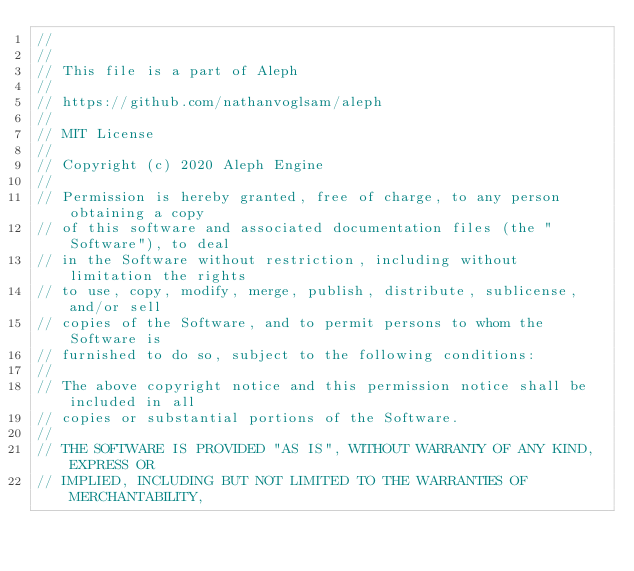<code> <loc_0><loc_0><loc_500><loc_500><_Rust_>//
//
// This file is a part of Aleph
//
// https://github.com/nathanvoglsam/aleph
//
// MIT License
//
// Copyright (c) 2020 Aleph Engine
//
// Permission is hereby granted, free of charge, to any person obtaining a copy
// of this software and associated documentation files (the "Software"), to deal
// in the Software without restriction, including without limitation the rights
// to use, copy, modify, merge, publish, distribute, sublicense, and/or sell
// copies of the Software, and to permit persons to whom the Software is
// furnished to do so, subject to the following conditions:
//
// The above copyright notice and this permission notice shall be included in all
// copies or substantial portions of the Software.
//
// THE SOFTWARE IS PROVIDED "AS IS", WITHOUT WARRANTY OF ANY KIND, EXPRESS OR
// IMPLIED, INCLUDING BUT NOT LIMITED TO THE WARRANTIES OF MERCHANTABILITY,</code> 